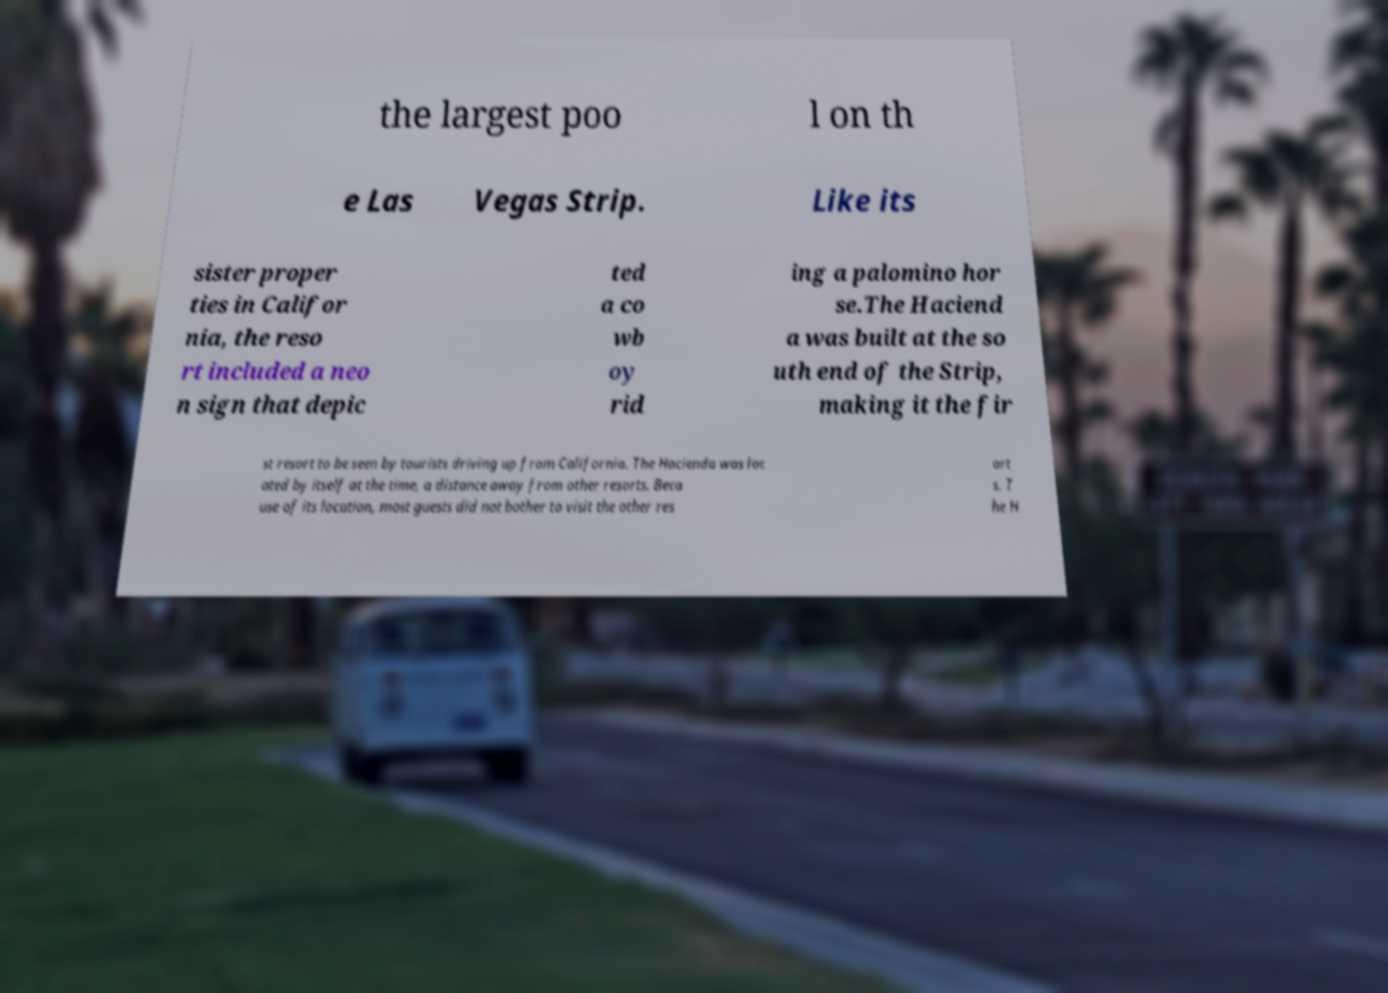I need the written content from this picture converted into text. Can you do that? the largest poo l on th e Las Vegas Strip. Like its sister proper ties in Califor nia, the reso rt included a neo n sign that depic ted a co wb oy rid ing a palomino hor se.The Haciend a was built at the so uth end of the Strip, making it the fir st resort to be seen by tourists driving up from California. The Hacienda was loc ated by itself at the time, a distance away from other resorts. Beca use of its location, most guests did not bother to visit the other res ort s. T he H 